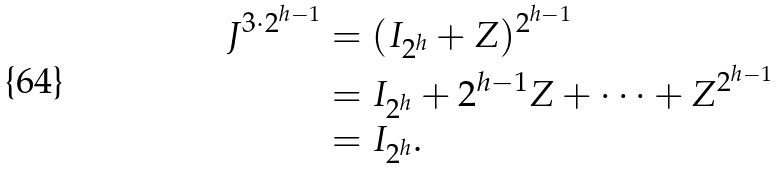Convert formula to latex. <formula><loc_0><loc_0><loc_500><loc_500>J ^ { 3 \cdot 2 ^ { h - 1 } } & = ( I _ { 2 ^ { h } } + Z ) ^ { 2 ^ { h - 1 } } \\ & = I _ { 2 ^ { h } } + 2 ^ { h - 1 } Z + \dots + Z ^ { 2 ^ { h - 1 } } \\ & = I _ { 2 ^ { h } } . \\</formula> 